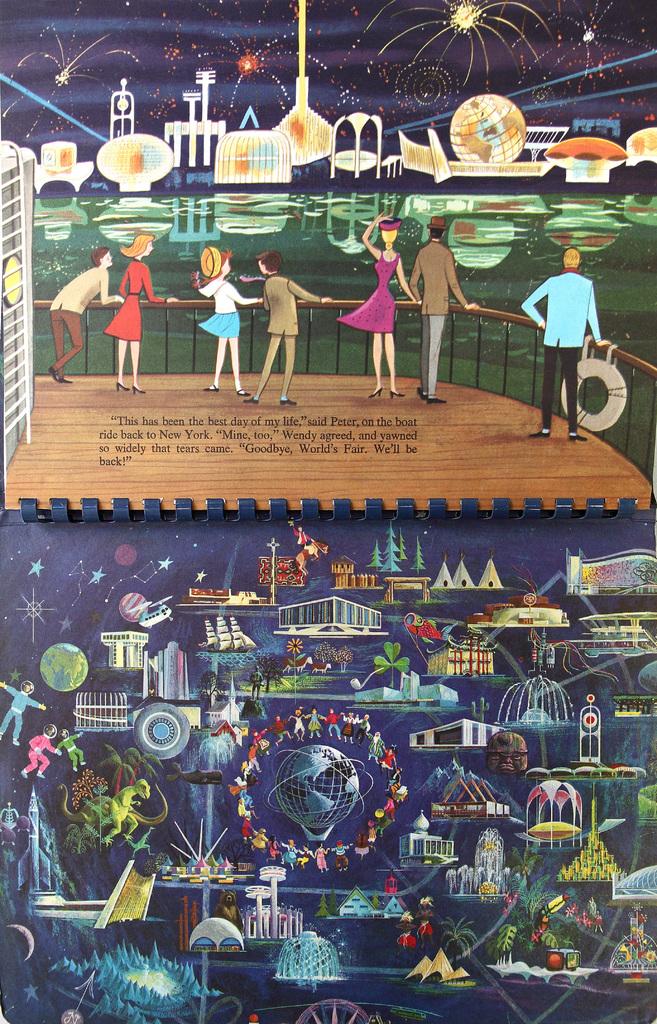What is written on the deck?
Offer a very short reply. Unanswerable. Who had the best day of their life?
Provide a short and direct response. Peter. 